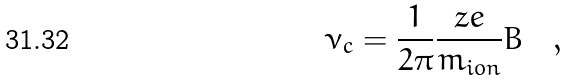Convert formula to latex. <formula><loc_0><loc_0><loc_500><loc_500>\nu _ { c } = \frac { 1 } { 2 \pi } \frac { z e } { m _ { i o n } } B \quad ,</formula> 